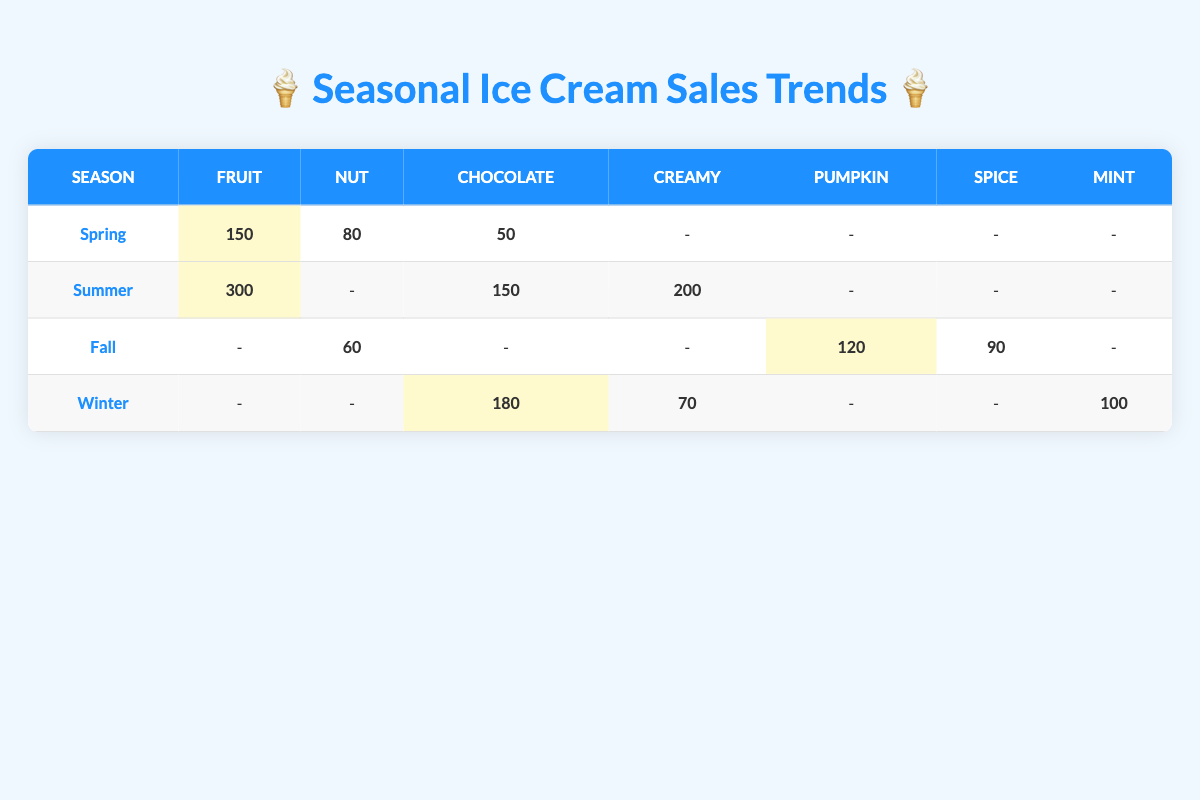What flavor category had the highest sales in Summer? In the Summer season, looking at the table, the sales units for each flavor category are: Fruit (300), Creamy (200), and Chocolate (150). The highest sales are for the Fruit flavor category with 300 sales units.
Answer: Fruit How many units of Chocolate were sold in Winter? According to the table, during Winter, the sales units for the Chocolate flavor category are recorded as 180. Therefore, the total units sold are 180.
Answer: 180 Which season had the least units sold for Nut flavor? Referring to the table, the units sold for Nut flavor are 80 in Spring, 60 in Fall, and no sales recorded for Summer and Winter. The least units sold for Nut flavor are in Fall with 60 sales units.
Answer: Fall What is the total sales for Creamy flavor across all seasons? From the table, the sales units for Creamy flavor are: 0 in Spring (represented as -), 200 in Summer, 0 in Fall (represented as -), and 70 in Winter. Adding these gives 0 + 200 + 0 + 70 = 270 units sold in total for Creamy flavor.
Answer: 270 Is there any season where Pumpkin flavor was not sold? The table indicates that Pumpkin flavor was only sold in Fall (120 units) and has no sales in Spring, Summer, or Winter (all represented as -). Thus, it can be concluded that Pumpkin was not sold in Spring, Summer, and Winter.
Answer: Yes 